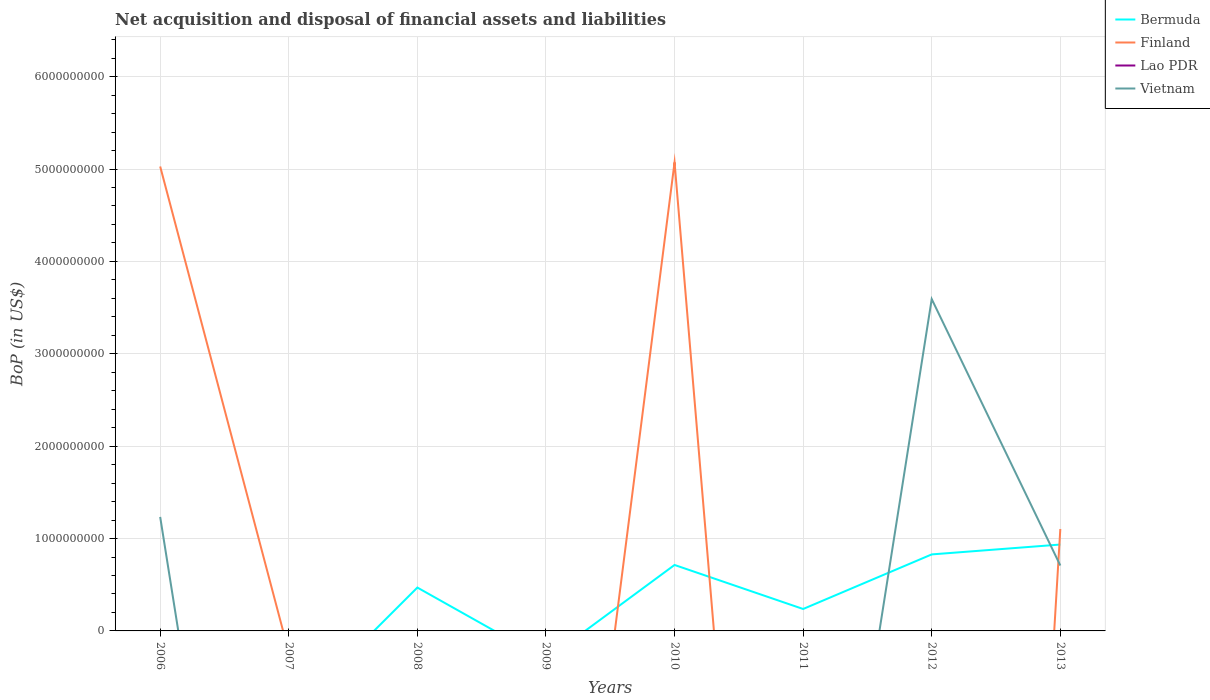How many different coloured lines are there?
Offer a very short reply. 3. Is the number of lines equal to the number of legend labels?
Offer a terse response. No. What is the total Balance of Payments in Bermuda in the graph?
Provide a short and direct response. -6.98e+08. What is the difference between the highest and the second highest Balance of Payments in Bermuda?
Make the answer very short. 9.35e+08. Is the Balance of Payments in Bermuda strictly greater than the Balance of Payments in Finland over the years?
Provide a short and direct response. No. How many lines are there?
Provide a succinct answer. 3. What is the difference between two consecutive major ticks on the Y-axis?
Your answer should be very brief. 1.00e+09. Are the values on the major ticks of Y-axis written in scientific E-notation?
Provide a short and direct response. No. Does the graph contain grids?
Give a very brief answer. Yes. Where does the legend appear in the graph?
Your answer should be compact. Top right. How many legend labels are there?
Provide a succinct answer. 4. What is the title of the graph?
Ensure brevity in your answer.  Net acquisition and disposal of financial assets and liabilities. What is the label or title of the Y-axis?
Offer a very short reply. BoP (in US$). What is the BoP (in US$) in Finland in 2006?
Ensure brevity in your answer.  5.03e+09. What is the BoP (in US$) in Vietnam in 2006?
Your answer should be very brief. 1.23e+09. What is the BoP (in US$) of Lao PDR in 2007?
Provide a short and direct response. 0. What is the BoP (in US$) of Bermuda in 2008?
Your answer should be compact. 4.69e+08. What is the BoP (in US$) of Finland in 2008?
Your response must be concise. 0. What is the BoP (in US$) in Lao PDR in 2008?
Ensure brevity in your answer.  0. What is the BoP (in US$) in Vietnam in 2008?
Make the answer very short. 0. What is the BoP (in US$) of Finland in 2009?
Give a very brief answer. 0. What is the BoP (in US$) of Lao PDR in 2009?
Offer a terse response. 0. What is the BoP (in US$) of Vietnam in 2009?
Offer a very short reply. 0. What is the BoP (in US$) of Bermuda in 2010?
Your answer should be very brief. 7.14e+08. What is the BoP (in US$) of Finland in 2010?
Ensure brevity in your answer.  5.07e+09. What is the BoP (in US$) of Bermuda in 2011?
Give a very brief answer. 2.37e+08. What is the BoP (in US$) in Finland in 2011?
Offer a very short reply. 0. What is the BoP (in US$) of Bermuda in 2012?
Make the answer very short. 8.28e+08. What is the BoP (in US$) in Finland in 2012?
Your response must be concise. 0. What is the BoP (in US$) in Vietnam in 2012?
Give a very brief answer. 3.59e+09. What is the BoP (in US$) of Bermuda in 2013?
Provide a succinct answer. 9.35e+08. What is the BoP (in US$) in Finland in 2013?
Make the answer very short. 1.10e+09. What is the BoP (in US$) in Vietnam in 2013?
Give a very brief answer. 7.08e+08. Across all years, what is the maximum BoP (in US$) in Bermuda?
Provide a short and direct response. 9.35e+08. Across all years, what is the maximum BoP (in US$) in Finland?
Provide a succinct answer. 5.07e+09. Across all years, what is the maximum BoP (in US$) of Vietnam?
Keep it short and to the point. 3.59e+09. Across all years, what is the minimum BoP (in US$) in Bermuda?
Offer a very short reply. 0. Across all years, what is the minimum BoP (in US$) in Finland?
Make the answer very short. 0. Across all years, what is the minimum BoP (in US$) in Vietnam?
Make the answer very short. 0. What is the total BoP (in US$) of Bermuda in the graph?
Ensure brevity in your answer.  3.18e+09. What is the total BoP (in US$) of Finland in the graph?
Provide a short and direct response. 1.12e+1. What is the total BoP (in US$) of Vietnam in the graph?
Your answer should be very brief. 5.53e+09. What is the difference between the BoP (in US$) of Finland in 2006 and that in 2010?
Your response must be concise. -4.50e+07. What is the difference between the BoP (in US$) in Vietnam in 2006 and that in 2012?
Provide a short and direct response. -2.36e+09. What is the difference between the BoP (in US$) in Finland in 2006 and that in 2013?
Ensure brevity in your answer.  3.92e+09. What is the difference between the BoP (in US$) in Vietnam in 2006 and that in 2013?
Your answer should be very brief. 5.26e+08. What is the difference between the BoP (in US$) of Bermuda in 2008 and that in 2010?
Your answer should be very brief. -2.45e+08. What is the difference between the BoP (in US$) of Bermuda in 2008 and that in 2011?
Give a very brief answer. 2.32e+08. What is the difference between the BoP (in US$) in Bermuda in 2008 and that in 2012?
Keep it short and to the point. -3.59e+08. What is the difference between the BoP (in US$) in Bermuda in 2008 and that in 2013?
Your response must be concise. -4.66e+08. What is the difference between the BoP (in US$) of Bermuda in 2010 and that in 2011?
Your response must be concise. 4.77e+08. What is the difference between the BoP (in US$) in Bermuda in 2010 and that in 2012?
Ensure brevity in your answer.  -1.14e+08. What is the difference between the BoP (in US$) of Bermuda in 2010 and that in 2013?
Provide a short and direct response. -2.21e+08. What is the difference between the BoP (in US$) in Finland in 2010 and that in 2013?
Ensure brevity in your answer.  3.97e+09. What is the difference between the BoP (in US$) in Bermuda in 2011 and that in 2012?
Your answer should be compact. -5.91e+08. What is the difference between the BoP (in US$) in Bermuda in 2011 and that in 2013?
Make the answer very short. -6.98e+08. What is the difference between the BoP (in US$) in Bermuda in 2012 and that in 2013?
Ensure brevity in your answer.  -1.07e+08. What is the difference between the BoP (in US$) in Vietnam in 2012 and that in 2013?
Provide a short and direct response. 2.88e+09. What is the difference between the BoP (in US$) in Finland in 2006 and the BoP (in US$) in Vietnam in 2012?
Your response must be concise. 1.44e+09. What is the difference between the BoP (in US$) in Finland in 2006 and the BoP (in US$) in Vietnam in 2013?
Give a very brief answer. 4.32e+09. What is the difference between the BoP (in US$) of Bermuda in 2008 and the BoP (in US$) of Finland in 2010?
Your response must be concise. -4.60e+09. What is the difference between the BoP (in US$) of Bermuda in 2008 and the BoP (in US$) of Vietnam in 2012?
Offer a very short reply. -3.12e+09. What is the difference between the BoP (in US$) of Bermuda in 2008 and the BoP (in US$) of Finland in 2013?
Keep it short and to the point. -6.34e+08. What is the difference between the BoP (in US$) in Bermuda in 2008 and the BoP (in US$) in Vietnam in 2013?
Provide a short and direct response. -2.39e+08. What is the difference between the BoP (in US$) of Bermuda in 2010 and the BoP (in US$) of Vietnam in 2012?
Keep it short and to the point. -2.88e+09. What is the difference between the BoP (in US$) in Finland in 2010 and the BoP (in US$) in Vietnam in 2012?
Provide a succinct answer. 1.48e+09. What is the difference between the BoP (in US$) of Bermuda in 2010 and the BoP (in US$) of Finland in 2013?
Give a very brief answer. -3.89e+08. What is the difference between the BoP (in US$) of Bermuda in 2010 and the BoP (in US$) of Vietnam in 2013?
Ensure brevity in your answer.  5.99e+06. What is the difference between the BoP (in US$) of Finland in 2010 and the BoP (in US$) of Vietnam in 2013?
Make the answer very short. 4.36e+09. What is the difference between the BoP (in US$) of Bermuda in 2011 and the BoP (in US$) of Vietnam in 2012?
Your answer should be very brief. -3.35e+09. What is the difference between the BoP (in US$) in Bermuda in 2011 and the BoP (in US$) in Finland in 2013?
Your answer should be very brief. -8.66e+08. What is the difference between the BoP (in US$) of Bermuda in 2011 and the BoP (in US$) of Vietnam in 2013?
Make the answer very short. -4.71e+08. What is the difference between the BoP (in US$) of Bermuda in 2012 and the BoP (in US$) of Finland in 2013?
Your answer should be compact. -2.75e+08. What is the difference between the BoP (in US$) of Bermuda in 2012 and the BoP (in US$) of Vietnam in 2013?
Provide a short and direct response. 1.20e+08. What is the average BoP (in US$) in Bermuda per year?
Make the answer very short. 3.98e+08. What is the average BoP (in US$) in Finland per year?
Your response must be concise. 1.40e+09. What is the average BoP (in US$) of Lao PDR per year?
Provide a succinct answer. 0. What is the average BoP (in US$) in Vietnam per year?
Your answer should be very brief. 6.92e+08. In the year 2006, what is the difference between the BoP (in US$) in Finland and BoP (in US$) in Vietnam?
Offer a terse response. 3.79e+09. In the year 2010, what is the difference between the BoP (in US$) in Bermuda and BoP (in US$) in Finland?
Keep it short and to the point. -4.36e+09. In the year 2012, what is the difference between the BoP (in US$) of Bermuda and BoP (in US$) of Vietnam?
Give a very brief answer. -2.76e+09. In the year 2013, what is the difference between the BoP (in US$) in Bermuda and BoP (in US$) in Finland?
Make the answer very short. -1.68e+08. In the year 2013, what is the difference between the BoP (in US$) in Bermuda and BoP (in US$) in Vietnam?
Provide a short and direct response. 2.27e+08. In the year 2013, what is the difference between the BoP (in US$) of Finland and BoP (in US$) of Vietnam?
Offer a very short reply. 3.95e+08. What is the ratio of the BoP (in US$) in Finland in 2006 to that in 2010?
Make the answer very short. 0.99. What is the ratio of the BoP (in US$) of Vietnam in 2006 to that in 2012?
Your answer should be compact. 0.34. What is the ratio of the BoP (in US$) of Finland in 2006 to that in 2013?
Ensure brevity in your answer.  4.56. What is the ratio of the BoP (in US$) of Vietnam in 2006 to that in 2013?
Your answer should be very brief. 1.74. What is the ratio of the BoP (in US$) of Bermuda in 2008 to that in 2010?
Make the answer very short. 0.66. What is the ratio of the BoP (in US$) in Bermuda in 2008 to that in 2011?
Your answer should be very brief. 1.98. What is the ratio of the BoP (in US$) in Bermuda in 2008 to that in 2012?
Ensure brevity in your answer.  0.57. What is the ratio of the BoP (in US$) in Bermuda in 2008 to that in 2013?
Keep it short and to the point. 0.5. What is the ratio of the BoP (in US$) in Bermuda in 2010 to that in 2011?
Keep it short and to the point. 3.01. What is the ratio of the BoP (in US$) in Bermuda in 2010 to that in 2012?
Offer a terse response. 0.86. What is the ratio of the BoP (in US$) in Bermuda in 2010 to that in 2013?
Ensure brevity in your answer.  0.76. What is the ratio of the BoP (in US$) in Finland in 2010 to that in 2013?
Offer a terse response. 4.6. What is the ratio of the BoP (in US$) of Bermuda in 2011 to that in 2012?
Ensure brevity in your answer.  0.29. What is the ratio of the BoP (in US$) in Bermuda in 2011 to that in 2013?
Ensure brevity in your answer.  0.25. What is the ratio of the BoP (in US$) in Bermuda in 2012 to that in 2013?
Keep it short and to the point. 0.89. What is the ratio of the BoP (in US$) of Vietnam in 2012 to that in 2013?
Offer a terse response. 5.07. What is the difference between the highest and the second highest BoP (in US$) in Bermuda?
Your answer should be compact. 1.07e+08. What is the difference between the highest and the second highest BoP (in US$) in Finland?
Offer a very short reply. 4.50e+07. What is the difference between the highest and the second highest BoP (in US$) of Vietnam?
Provide a succinct answer. 2.36e+09. What is the difference between the highest and the lowest BoP (in US$) of Bermuda?
Give a very brief answer. 9.35e+08. What is the difference between the highest and the lowest BoP (in US$) of Finland?
Give a very brief answer. 5.07e+09. What is the difference between the highest and the lowest BoP (in US$) of Vietnam?
Ensure brevity in your answer.  3.59e+09. 